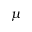<formula> <loc_0><loc_0><loc_500><loc_500>\mu</formula> 